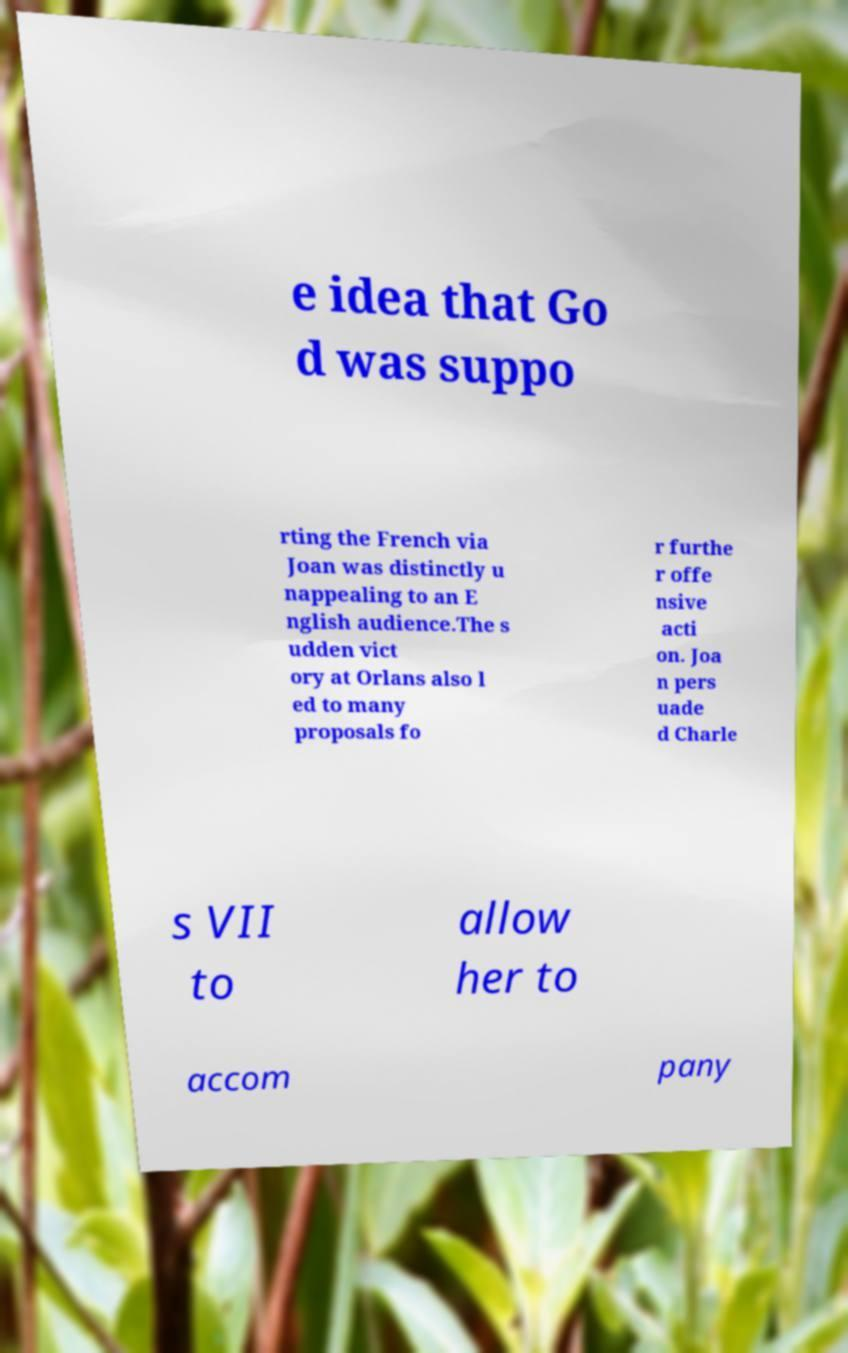There's text embedded in this image that I need extracted. Can you transcribe it verbatim? e idea that Go d was suppo rting the French via Joan was distinctly u nappealing to an E nglish audience.The s udden vict ory at Orlans also l ed to many proposals fo r furthe r offe nsive acti on. Joa n pers uade d Charle s VII to allow her to accom pany 